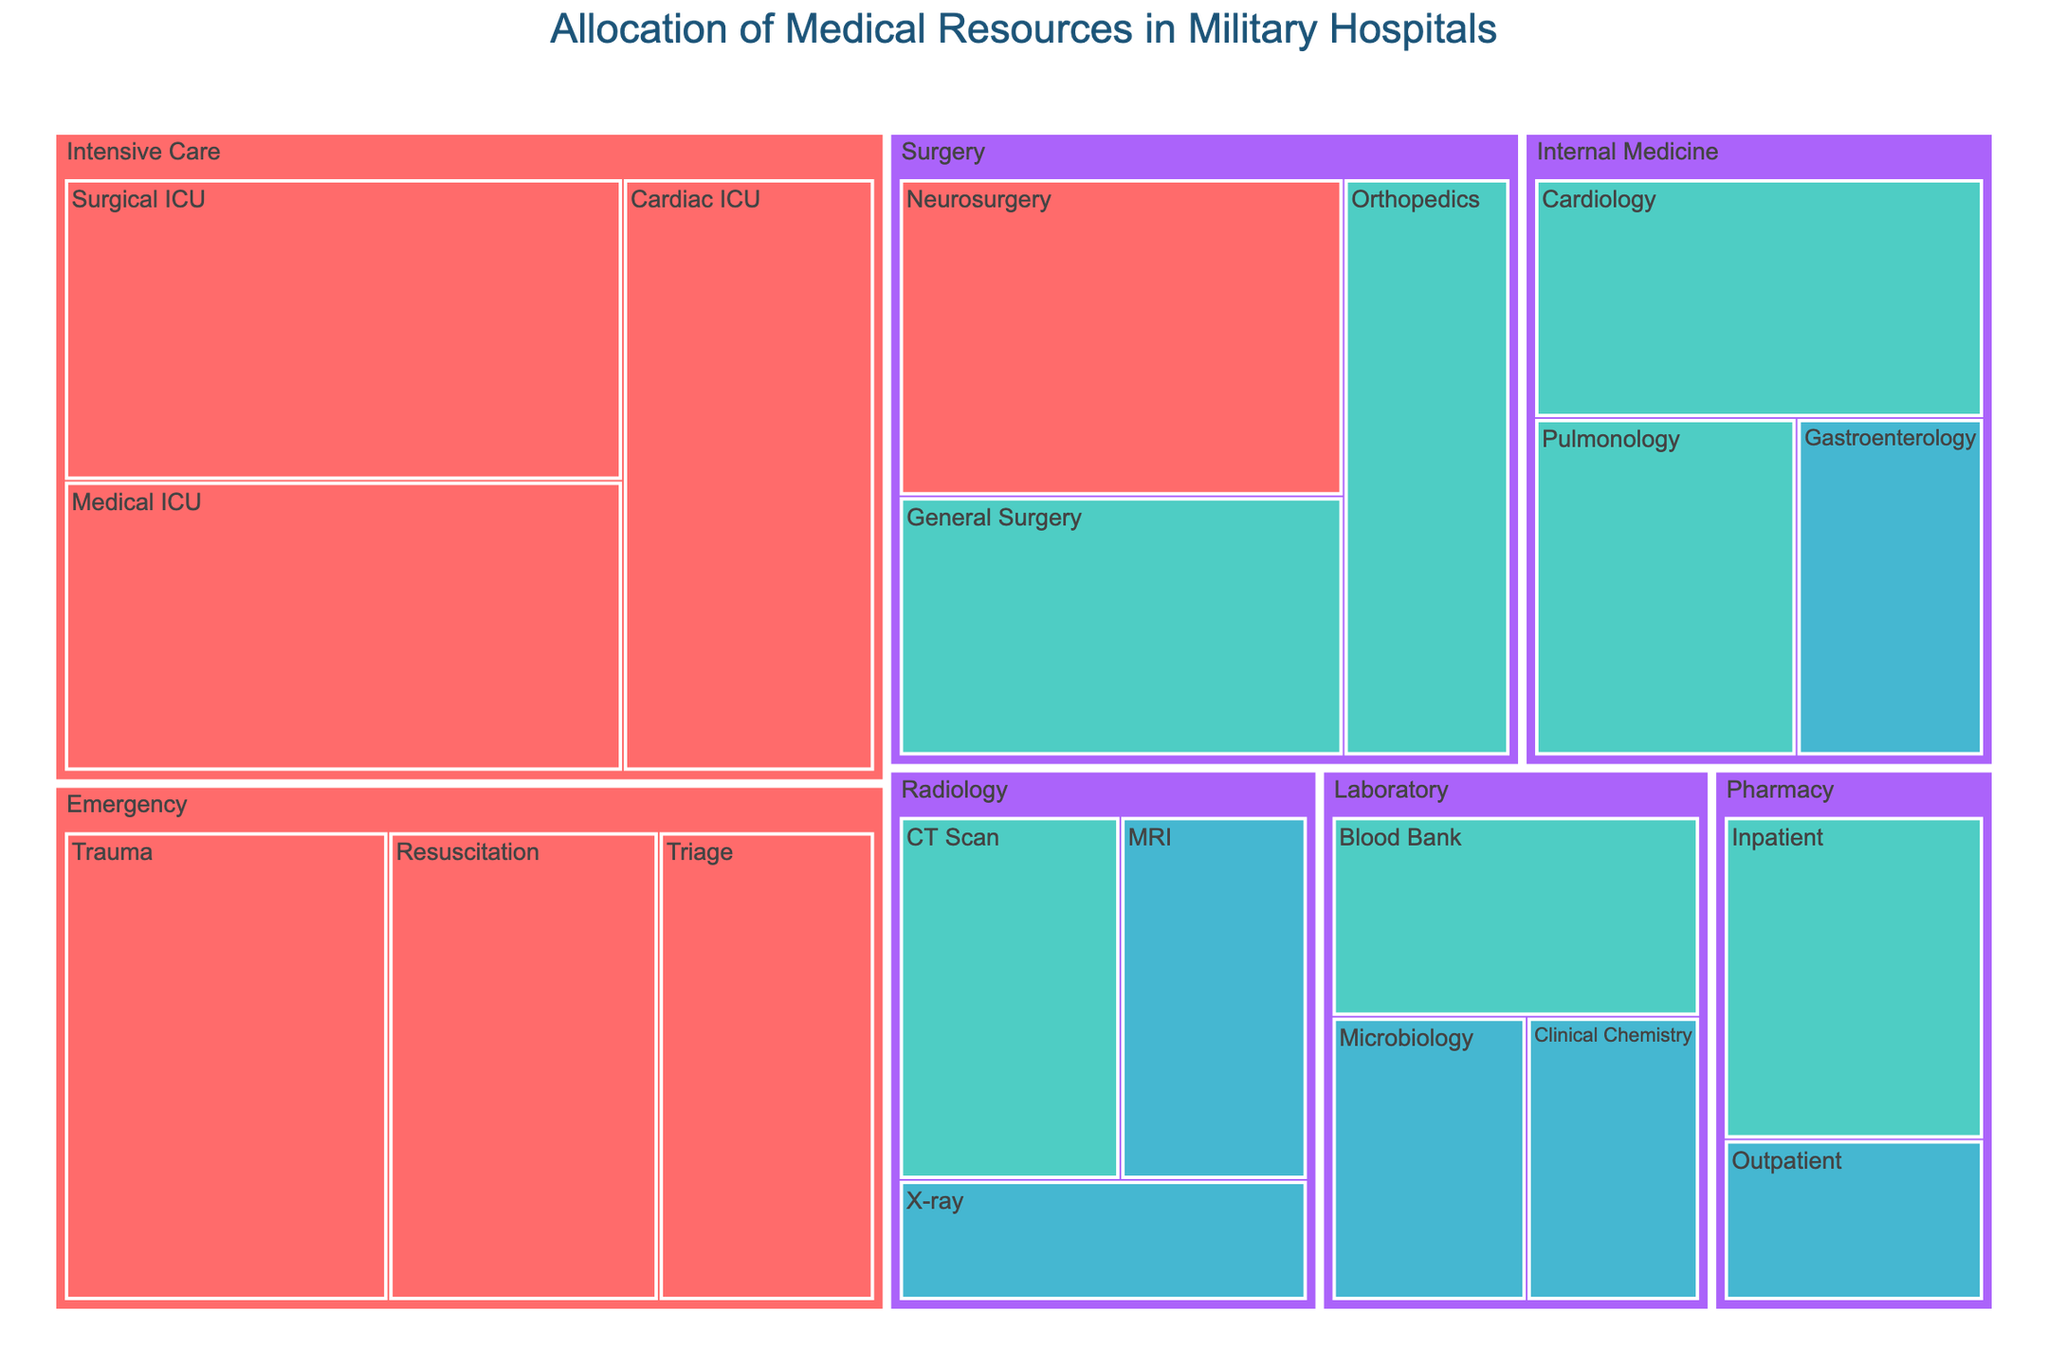What's the title of the figure? The title is usually located at the top of the figure. Here, the title text reads "Allocation of Medical Resources in Military Hospitals," which is visible in the figure.
Answer: Allocation of Medical Resources in Military Hospitals Which department uses the most resources? We need to identify the largest section within the figure. The Intensive Care department, combining Surgical ICU, Medical ICU, and Cardiac ICU, has the highest total resources.
Answer: Intensive Care How many subdepartments are there in the Emergency department? Within the Emergency department section, we can count the subdivisions. The Emergency department has three subdepartments: Trauma, Triage, and Resuscitation.
Answer: 3 Compare the resources allocated to Emergency and Surgery departments. Which one has more? Summing the resources for each subdepartment within these departments: Emergency (1200+800+1000 = 3000) and Surgery (900+750+1100 = 2750). Emergency has more resources.
Answer: Emergency What's the average resource allocation for the Radiology department? Calculate the sum of the resources for each subdepartment in Radiology and divide by the number of subdepartments. The allocation is (400+650+550)/3 = 533.33.
Answer: 533.33 Which department has the least total resource allocation? Sum the resources for subdepartments within each department and compare. Pharmacy subdepartments sum to the lowest total: 700+350 = 1050.
Answer: Pharmacy What is the total resource allocation for high-urgency cases? Sum the resources allocated to all high-urgency subdepartments: 1200+800+1000+1100+1300+1250+1150 = 7800.
Answer: 7800 How does the resource allocation for Internal Medicine subdepartments compare to those of the Intensive Care department? Sum the resources for each department: Internal Medicine (850+700+500 = 2050) and Intensive Care (1300+1250+1150 = 3700). Intensive Care has more resources.
Answer: Intensive Care What color represents medium-urgency levels in the treemap? The color legend maps urgency levels to colors. Medium urgency is represented by what appears as a shade of greenish-blue.
Answer: Greenish-blue Identify the subdepartment with the lowest resource allocation. From the visual data, Laboratory's Clinical Chemistry subdepartment has the lowest allocation with 400 resources.
Answer: Clinical Chemistry 